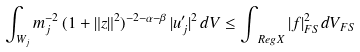<formula> <loc_0><loc_0><loc_500><loc_500>\int _ { W _ { j } } m _ { j } ^ { - 2 } \, ( 1 + \| z \| ^ { 2 } ) ^ { - 2 - \alpha - \beta } \, | u ^ { \prime } _ { j } | ^ { 2 } \, d V \leq \int _ { \ R e g X } | f | _ { F S } ^ { 2 } d V _ { F S }</formula> 